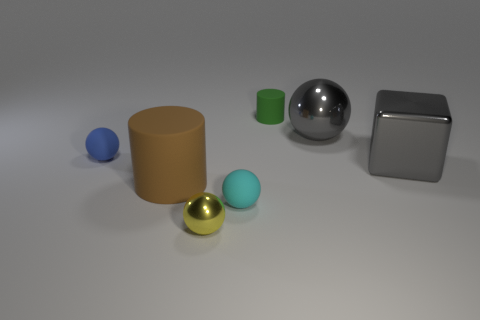There is a metallic object that is the same color as the cube; what is its size?
Your answer should be compact. Large. What is the size of the rubber object that is behind the block and to the left of the small green cylinder?
Your answer should be very brief. Small. Do the gray sphere and the green cylinder have the same size?
Make the answer very short. No. There is a small ball that is on the right side of the yellow shiny ball; is its color the same as the large rubber cylinder?
Keep it short and to the point. No. What number of tiny green things are left of the blue matte object?
Ensure brevity in your answer.  0. Are there more blue objects than tiny purple objects?
Ensure brevity in your answer.  Yes. There is a object that is both left of the cyan rubber ball and in front of the brown rubber cylinder; what shape is it?
Your answer should be compact. Sphere. Are there any tiny blue things?
Your answer should be compact. Yes. There is another thing that is the same shape as the large brown object; what material is it?
Your answer should be compact. Rubber. The tiny thing that is on the left side of the metal sphere that is left of the cylinder that is behind the gray shiny ball is what shape?
Your answer should be very brief. Sphere. 